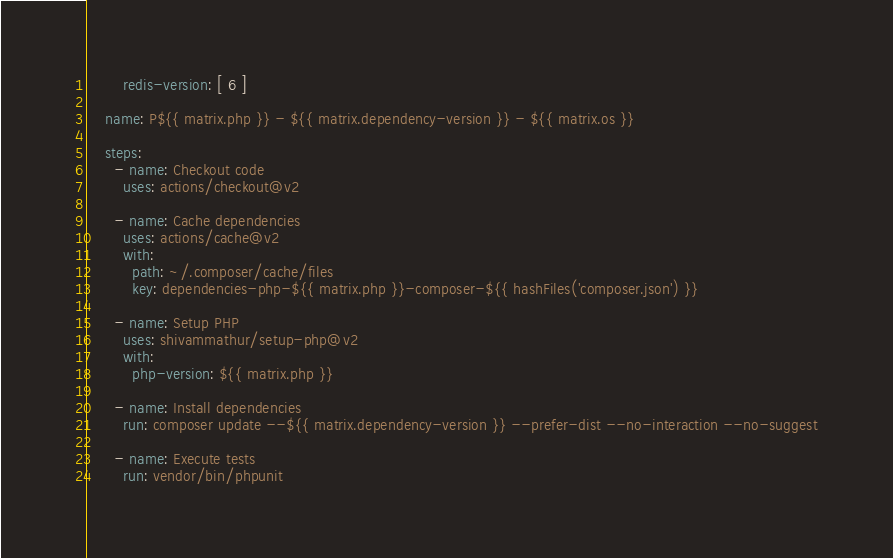<code> <loc_0><loc_0><loc_500><loc_500><_YAML_>        redis-version: [ 6 ]

    name: P${{ matrix.php }} - ${{ matrix.dependency-version }} - ${{ matrix.os }}

    steps:
      - name: Checkout code
        uses: actions/checkout@v2

      - name: Cache dependencies
        uses: actions/cache@v2
        with:
          path: ~/.composer/cache/files
          key: dependencies-php-${{ matrix.php }}-composer-${{ hashFiles('composer.json') }}

      - name: Setup PHP
        uses: shivammathur/setup-php@v2
        with:
          php-version: ${{ matrix.php }}

      - name: Install dependencies
        run: composer update --${{ matrix.dependency-version }} --prefer-dist --no-interaction --no-suggest

      - name: Execute tests
        run: vendor/bin/phpunit
</code> 